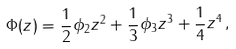<formula> <loc_0><loc_0><loc_500><loc_500>\Phi ( z ) = \frac { 1 } { 2 } \phi _ { 2 } z ^ { 2 } + \frac { 1 } { 3 } \phi _ { 3 } z ^ { 3 } + \frac { 1 } { 4 } z ^ { 4 } \, ,</formula> 